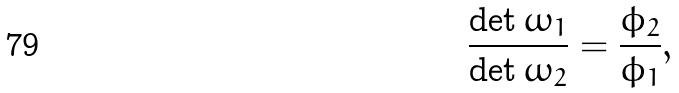Convert formula to latex. <formula><loc_0><loc_0><loc_500><loc_500>\frac { \det \omega _ { 1 } } { \det \omega _ { 2 } } = \frac { \phi _ { 2 } } { \phi _ { 1 } } ,</formula> 